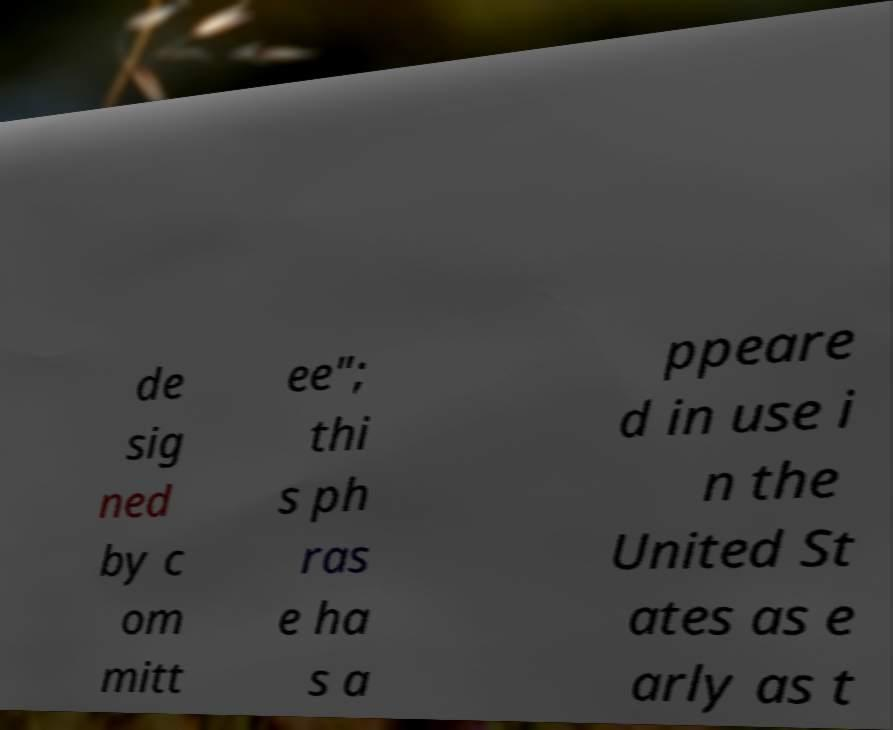Can you read and provide the text displayed in the image?This photo seems to have some interesting text. Can you extract and type it out for me? de sig ned by c om mitt ee"; thi s ph ras e ha s a ppeare d in use i n the United St ates as e arly as t 